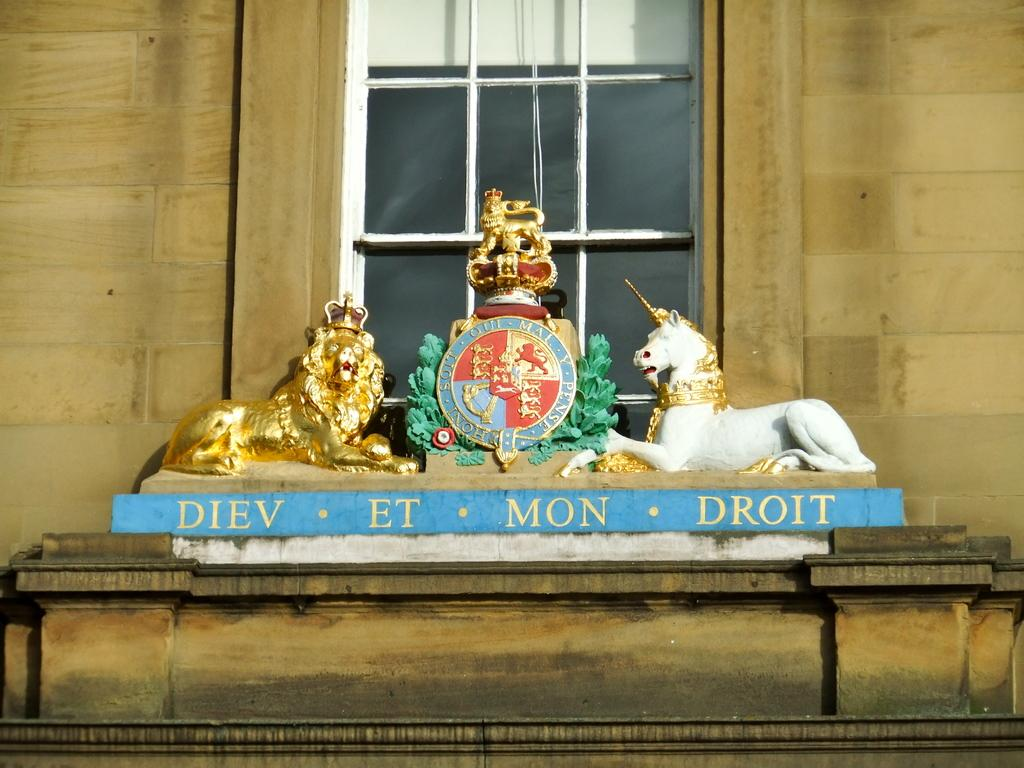What type of objects can be seen in the image? There are statues in the image. What else can be found in the image besides the statues? There is text written on a pillar in the image. What architectural feature is visible in the image? There is a wall visible in the image. Can you describe the wall in the image? There is a window in the wall in the image. What type of industry is depicted in the image? There is no industry depicted in the image; it features statues, text on a pillar, a wall, and a window. 